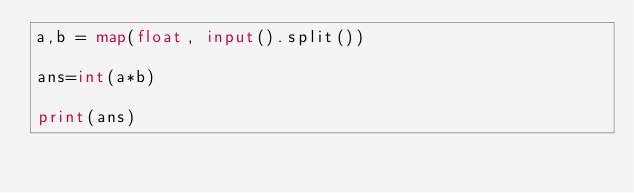Convert code to text. <code><loc_0><loc_0><loc_500><loc_500><_Python_>a,b = map(float, input().split())

ans=int(a*b)

print(ans)</code> 